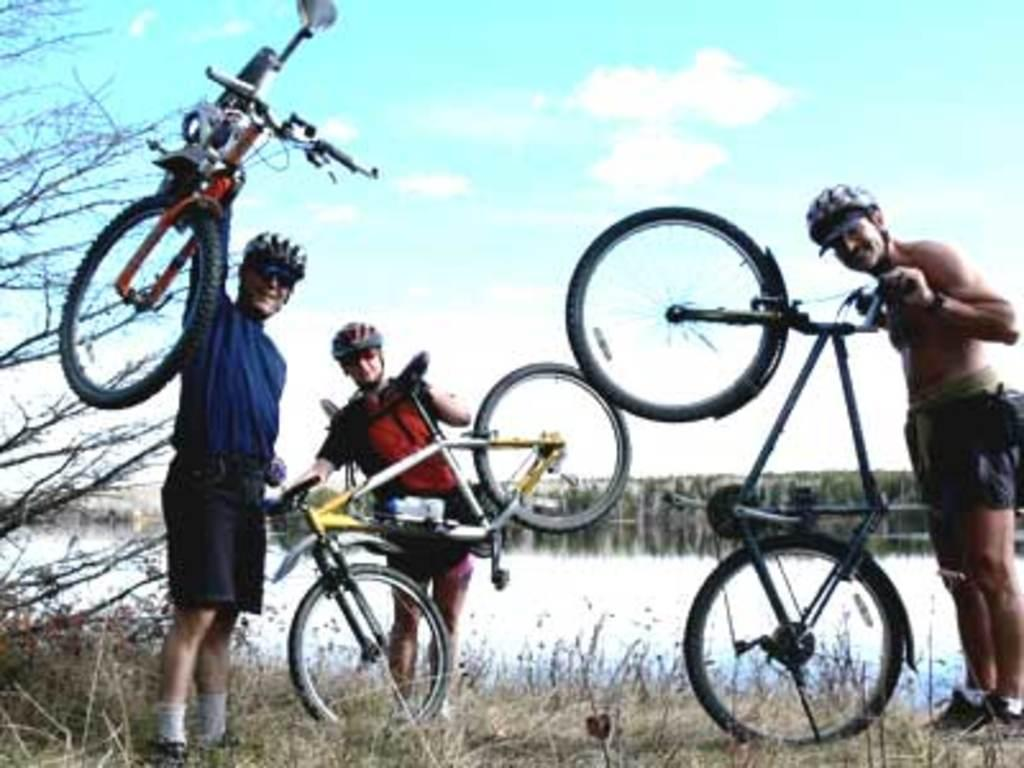How many people are in the image? There are three people in the image. What are the people wearing on their heads? The people are wearing helmets. What type of footwear are the people wearing? The people are wearing shoes. What type of vehicles can be seen in the image? There are bicycles in the image. What type of vegetation is present in the image? There is grass, a tree, and a plant in the image. What is the condition of the sky in the image? The sky is cloudy in the image. Can you tell me how many times the floor is mentioned in the image? The term "floor" is not mentioned in the image. What type of porter is assisting the people in the image? There is no porter mentioned or visible in the image. 